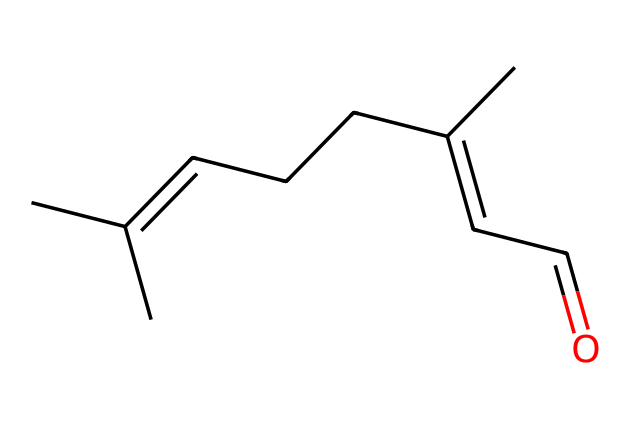What is the chemical name of this compound? The SMILES representation given corresponds to a compound with the aldehyde functional group, characterized by the presence of a carbonyl group (C=O) at the end of a carbon chain. When analyzed, this specific structure is known as citral.
Answer: citral How many carbon atoms are present in this molecule? By analyzing the SMILES representation, we can count the carbon (C) symbols. There are six carbon atoms in the longest chain and two in the branched section, totaling eight carbon atoms.
Answer: eight What functional group is present in this compound? The presence of the carbonyl group (C=O) at the terminal position indicates that this molecule has an aldehyde functional group. This is specific to aldehydes, which have carbonyl groups bonded directly to a hydrogen atom.
Answer: aldehyde What is the total number of hydrogen atoms in this compound? In the SMILES structure, we note that for each carbon atom, two hydrogen atoms typically bond, except for the carbon that is part of the aldehyde group, which has one hydrogen. After counting all the connected hydrogens through the chain, the total comes to 14 hydrogen atoms.
Answer: fourteen Is this aldehyde a straight-chain or branched structure? Looking at the SMILES, we can see the carbon chain is branched, as there are substituents off the main chain, indicating the non-linear arrangement of the carbons. Specifically, the presence of branching points suggests a branched structure.
Answer: branched What is the significance of the aldehyde group in this compound? The aldehyde group is crucial as it gives citral its characteristic properties, such as its aroma and reactivity. Aldehydes can participate in various reactions, including oxidation to carboxylic acids, influencing the properties of aroma compounds like citral.
Answer: aroma and reactivity 